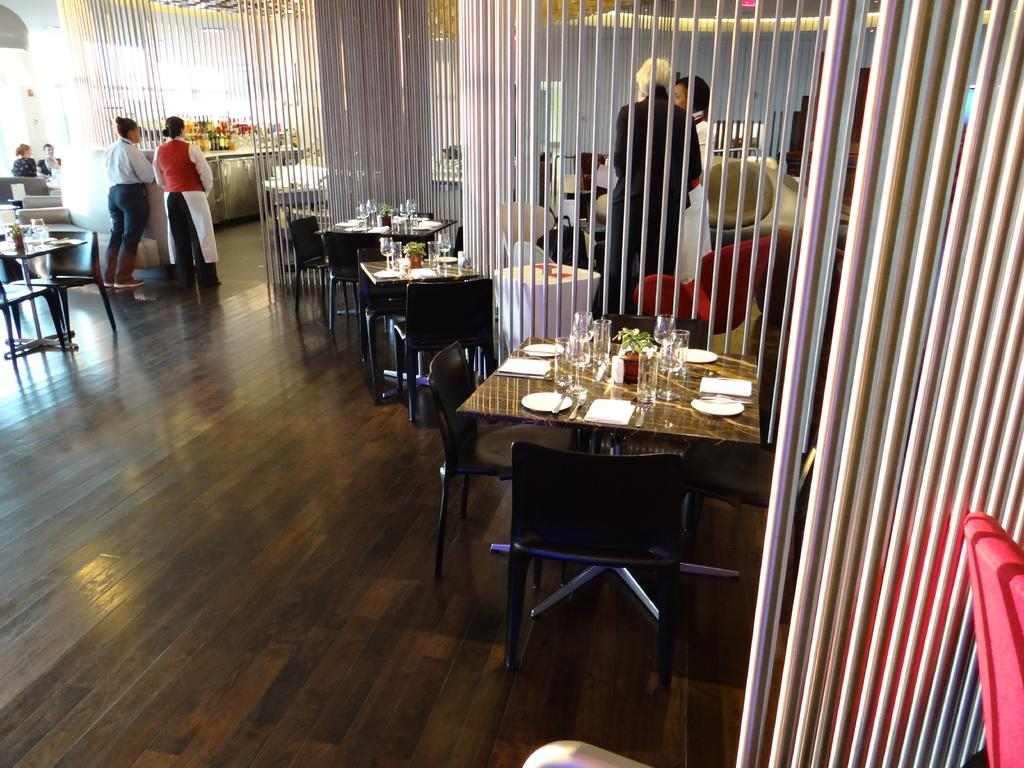What material is the floor made of in the image? The floor is made of wood. What type of furniture can be seen in the image? There are chairs and tables in the image. Are there any people present in the image? Yes, there are people in the image. What are the rods used for in the image? The purpose of the rods is not specified in the provided facts. What items can be found on the tables in the image? There are glasses, plates, plants, and other things on the tables. What type of calculator is the queen using in the image? There is no queen or calculator present in the image. What color is the shirt worn by the person in the image? The provided facts do not mention any clothing or colors of clothing. 